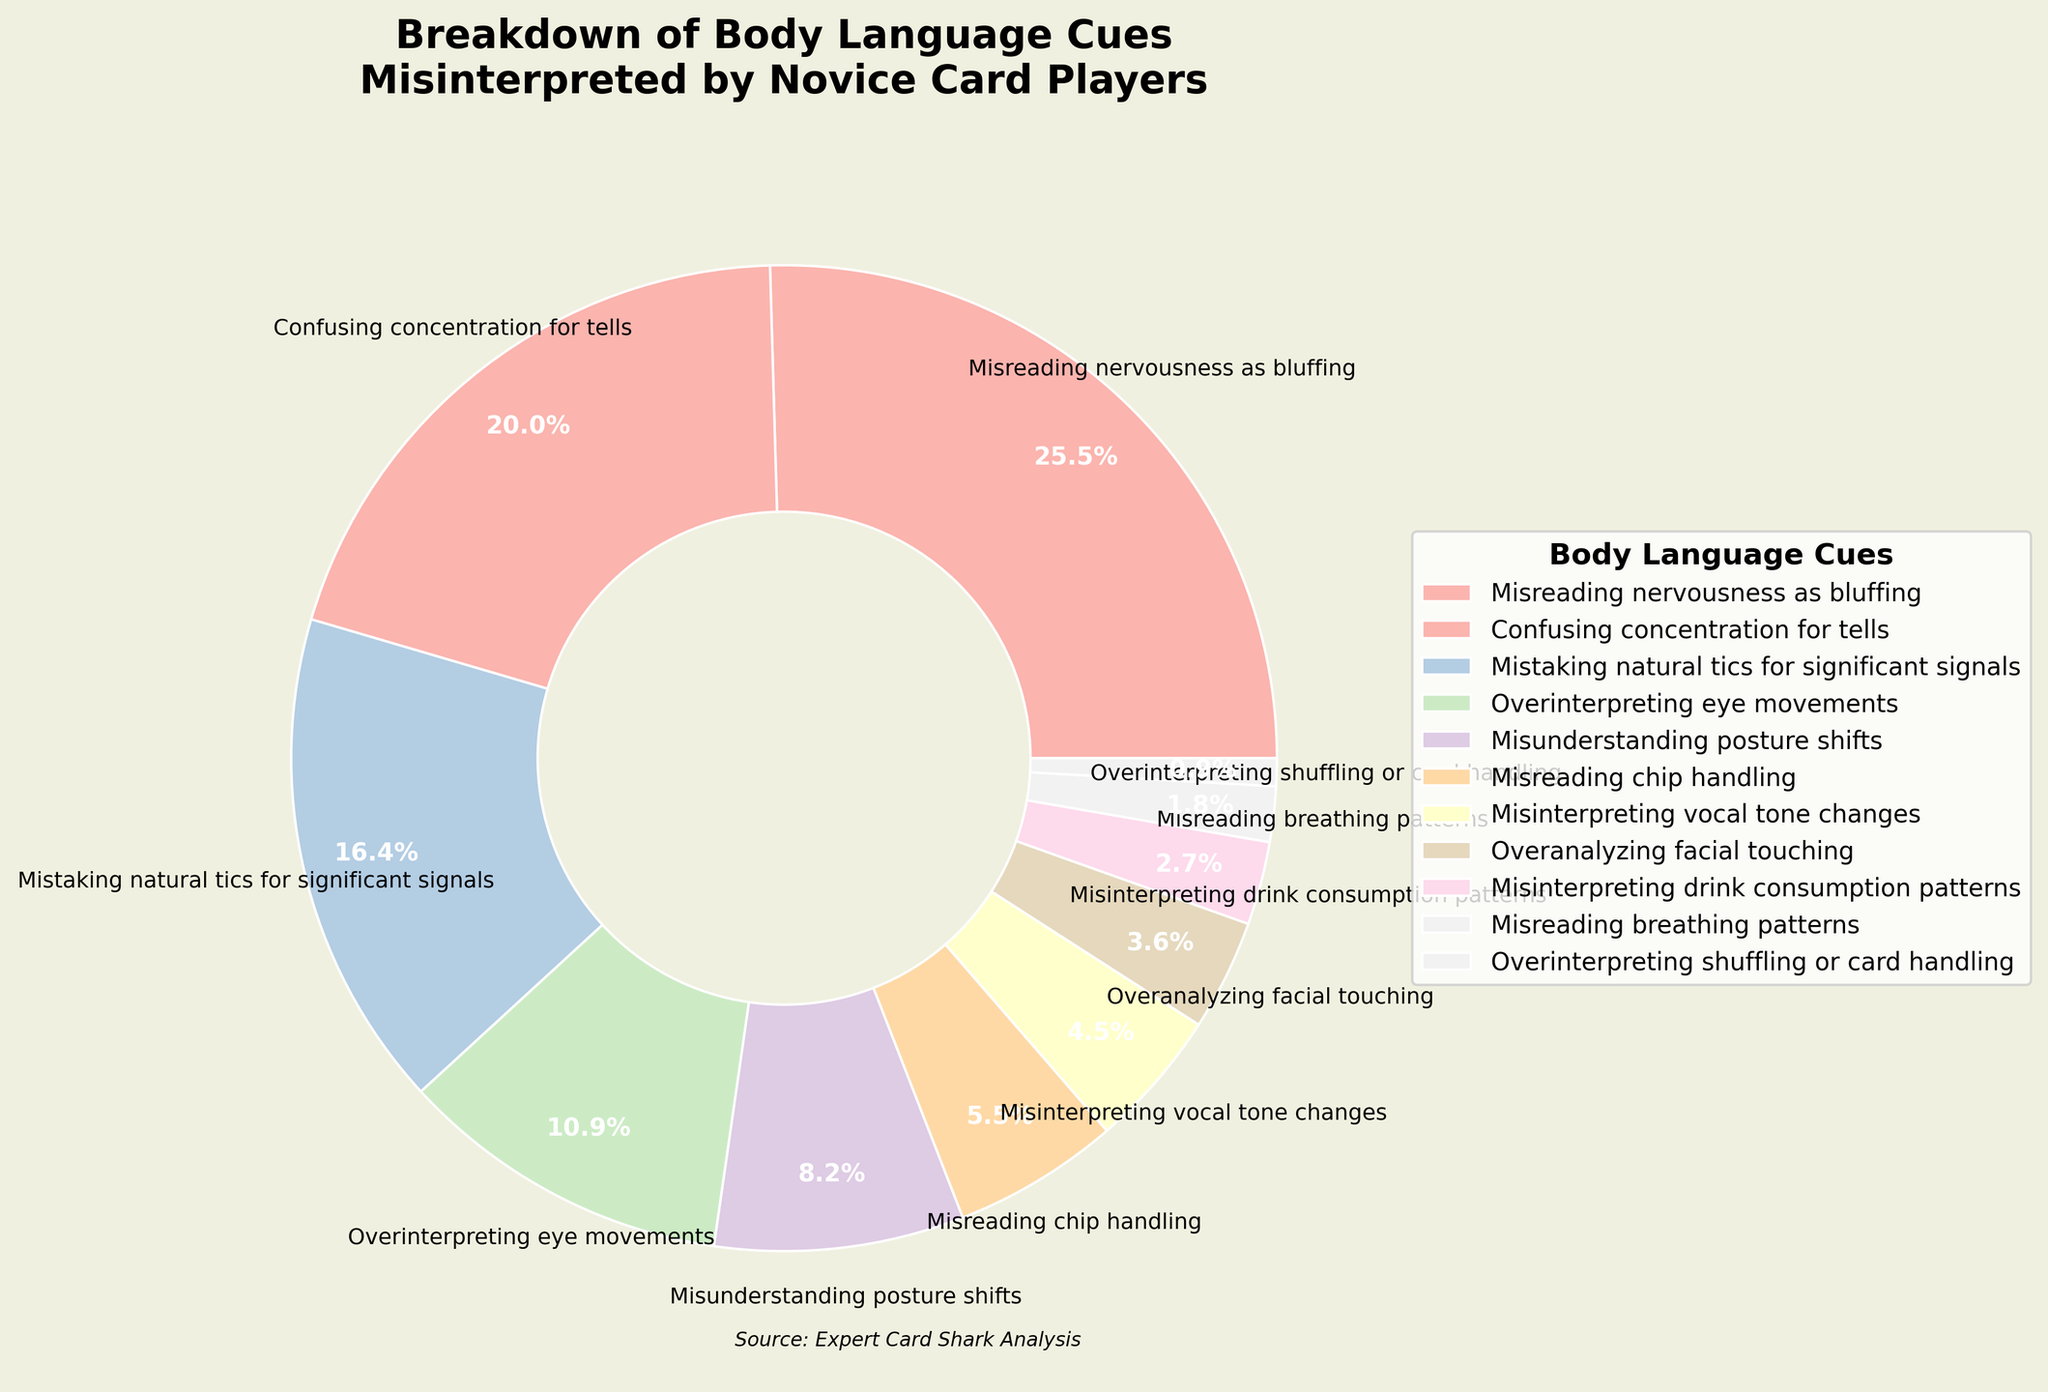What's the most commonly misinterpreted body language cue by novice card players? The slice representing "Misreading nervousness as bluffing" is the largest in the pie chart.
Answer: Misreading nervousness as bluffing Which body language cue is the least commonly misinterpreted by novice card players? The slice representing "Overinterpreting shuffling or card handling" is the smallest in the pie chart.
Answer: Overinterpreting shuffling or card handling What percentage of cues involve confusion due to facial movements, like eye movements and facial touching? Add percentages for "Overinterpreting eye movements" (12%) and "Overanalyzing facial touching" (4%). 12 + 4 = 16%.
Answer: 16% Compare the misinterpretation of posture shifts and chip handling cues. Which one is higher, and by what percentage? Posture shifts are 9%, and chip handling is 6%. The difference is 9 - 6 = 3%.
Answer: Posture shifts by 3% Is the proportion of misinterpreting natural tics higher or lower than confusing concentration for tells? By how much? Natural tics (18%) and concentration (22%). The difference is 22 - 18 = 4%. It’s lower by 4%.
Answer: Lower by 4% What is the total percentage of misinterpreted cues related to body movements, such as posture shifts, chip handling, and shuffling/card handling? Add percentages for "Misunderstanding posture shifts" (9%), "Misreading chip handling" (6%), and "Overinterpreting shuffling or card handling" (1%). 9 + 6 + 1 = 16%.
Answer: 16% How does the misinterpretation percentage of vocal tone changes compare to that of breathing patterns? Vocal tone changes (5%), breathing patterns (2%). Vocal tone changes are higher.
Answer: Vocal tone changes are higher What proportion of the cues listed is misinterpreted at a level below 10%? The cues with percentages below 10% are "Misunderstanding posture shifts" (9%), "Misreading chip handling" (6%), "Misinterpreting vocal tone changes" (5%), "Overanalyzing facial touching" (4%), "Misinterpreting drink consumption patterns" (3%), "Misreading breathing patterns" (2%), and "Overinterpreting shuffling or card handling" (1%).
Answer: 7 cues Does the misinterpretation percentage of confusing concentration for tells and mistaking natural tics for significant signals combined surpass 40%? Concentration (22%) and natural tics (18%). Combined, they are 22 + 18 = 40%.
Answer: No Which cue has a proportion closest to the average percentage of all cues? Calculate the average percentage: (28+22+18+12+9+6+5+4+3+2+1)/11. The average is 10%. The closest proportion is "Misunderstanding posture shifts" (9%).
Answer: Misunderstanding posture shifts 